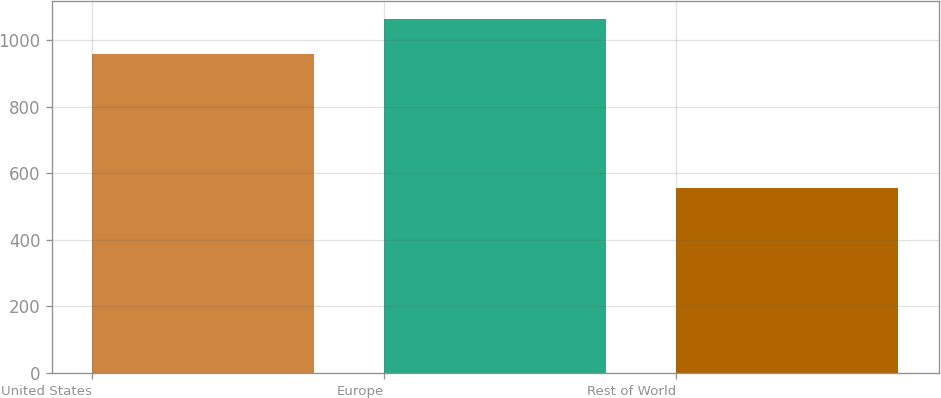<chart> <loc_0><loc_0><loc_500><loc_500><bar_chart><fcel>United States<fcel>Europe<fcel>Rest of World<nl><fcel>958.8<fcel>1065.3<fcel>557.4<nl></chart> 